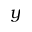<formula> <loc_0><loc_0><loc_500><loc_500>y</formula> 